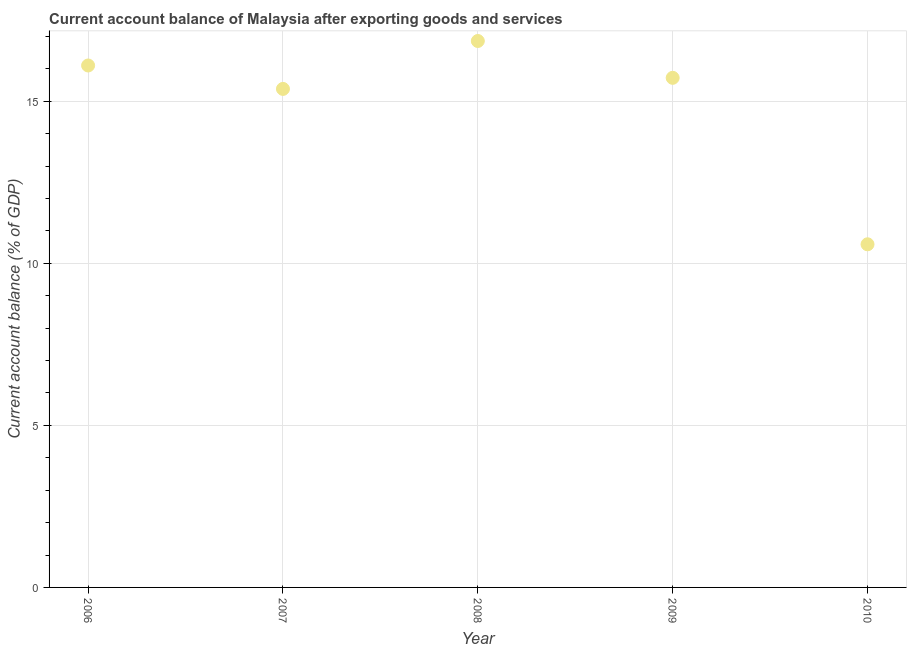What is the current account balance in 2007?
Provide a short and direct response. 15.38. Across all years, what is the maximum current account balance?
Your response must be concise. 16.86. Across all years, what is the minimum current account balance?
Make the answer very short. 10.59. In which year was the current account balance minimum?
Keep it short and to the point. 2010. What is the sum of the current account balance?
Your response must be concise. 74.65. What is the difference between the current account balance in 2007 and 2010?
Ensure brevity in your answer.  4.79. What is the average current account balance per year?
Offer a terse response. 14.93. What is the median current account balance?
Provide a short and direct response. 15.72. In how many years, is the current account balance greater than 9 %?
Your answer should be compact. 5. What is the ratio of the current account balance in 2008 to that in 2010?
Offer a very short reply. 1.59. Is the difference between the current account balance in 2007 and 2008 greater than the difference between any two years?
Your answer should be very brief. No. What is the difference between the highest and the second highest current account balance?
Provide a succinct answer. 0.76. Is the sum of the current account balance in 2006 and 2010 greater than the maximum current account balance across all years?
Ensure brevity in your answer.  Yes. What is the difference between the highest and the lowest current account balance?
Your response must be concise. 6.27. In how many years, is the current account balance greater than the average current account balance taken over all years?
Offer a terse response. 4. Does the current account balance monotonically increase over the years?
Offer a very short reply. No. Does the graph contain any zero values?
Provide a short and direct response. No. Does the graph contain grids?
Ensure brevity in your answer.  Yes. What is the title of the graph?
Provide a succinct answer. Current account balance of Malaysia after exporting goods and services. What is the label or title of the Y-axis?
Your answer should be very brief. Current account balance (% of GDP). What is the Current account balance (% of GDP) in 2006?
Your answer should be compact. 16.1. What is the Current account balance (% of GDP) in 2007?
Your answer should be compact. 15.38. What is the Current account balance (% of GDP) in 2008?
Ensure brevity in your answer.  16.86. What is the Current account balance (% of GDP) in 2009?
Provide a succinct answer. 15.72. What is the Current account balance (% of GDP) in 2010?
Provide a succinct answer. 10.59. What is the difference between the Current account balance (% of GDP) in 2006 and 2007?
Ensure brevity in your answer.  0.72. What is the difference between the Current account balance (% of GDP) in 2006 and 2008?
Your answer should be very brief. -0.76. What is the difference between the Current account balance (% of GDP) in 2006 and 2009?
Provide a short and direct response. 0.38. What is the difference between the Current account balance (% of GDP) in 2006 and 2010?
Provide a short and direct response. 5.52. What is the difference between the Current account balance (% of GDP) in 2007 and 2008?
Make the answer very short. -1.48. What is the difference between the Current account balance (% of GDP) in 2007 and 2009?
Make the answer very short. -0.34. What is the difference between the Current account balance (% of GDP) in 2007 and 2010?
Offer a terse response. 4.79. What is the difference between the Current account balance (% of GDP) in 2008 and 2009?
Provide a short and direct response. 1.14. What is the difference between the Current account balance (% of GDP) in 2008 and 2010?
Offer a terse response. 6.27. What is the difference between the Current account balance (% of GDP) in 2009 and 2010?
Ensure brevity in your answer.  5.14. What is the ratio of the Current account balance (% of GDP) in 2006 to that in 2007?
Offer a terse response. 1.05. What is the ratio of the Current account balance (% of GDP) in 2006 to that in 2008?
Your response must be concise. 0.95. What is the ratio of the Current account balance (% of GDP) in 2006 to that in 2009?
Your answer should be compact. 1.02. What is the ratio of the Current account balance (% of GDP) in 2006 to that in 2010?
Offer a very short reply. 1.52. What is the ratio of the Current account balance (% of GDP) in 2007 to that in 2008?
Give a very brief answer. 0.91. What is the ratio of the Current account balance (% of GDP) in 2007 to that in 2010?
Offer a terse response. 1.45. What is the ratio of the Current account balance (% of GDP) in 2008 to that in 2009?
Keep it short and to the point. 1.07. What is the ratio of the Current account balance (% of GDP) in 2008 to that in 2010?
Your answer should be compact. 1.59. What is the ratio of the Current account balance (% of GDP) in 2009 to that in 2010?
Provide a succinct answer. 1.49. 